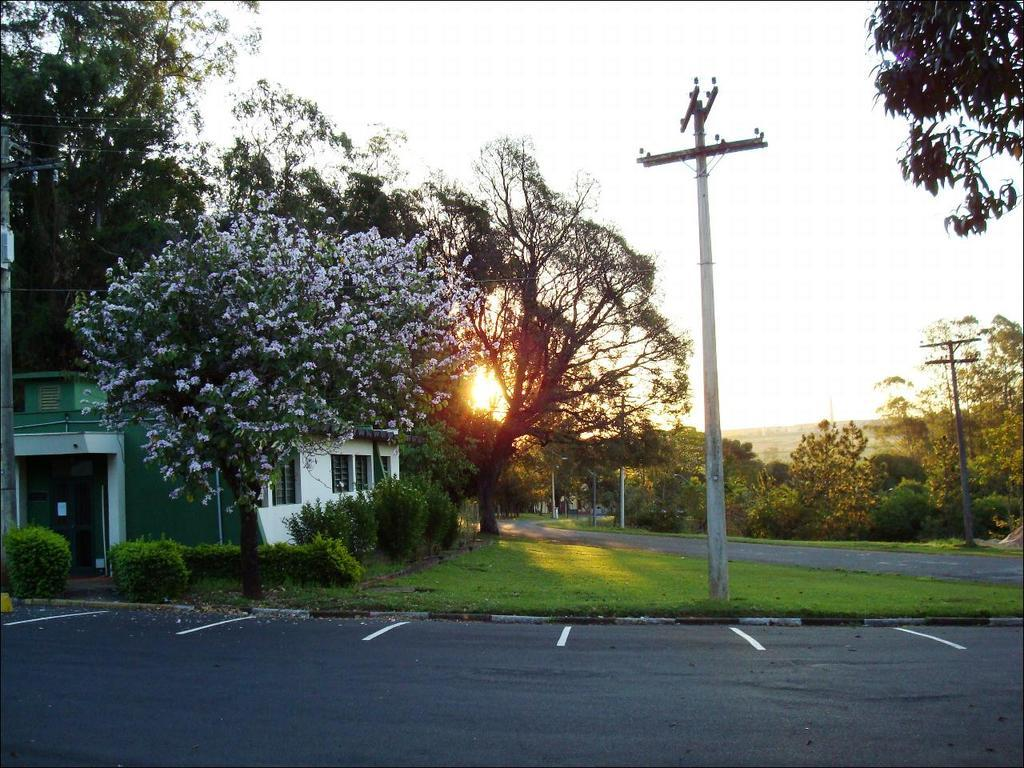What is the main feature of the image? There is a road in the image. What can be seen in the distance behind the road? There is a house, electric poles, trees, and the sky visible in the background of the image. Where is the tray of linen being used in the image? There is no tray or linen present in the image. What role does the grandfather play in the image? There is no grandfather present in the image. 